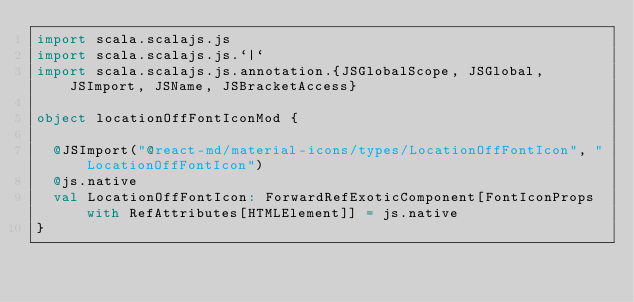Convert code to text. <code><loc_0><loc_0><loc_500><loc_500><_Scala_>import scala.scalajs.js
import scala.scalajs.js.`|`
import scala.scalajs.js.annotation.{JSGlobalScope, JSGlobal, JSImport, JSName, JSBracketAccess}

object locationOffFontIconMod {
  
  @JSImport("@react-md/material-icons/types/LocationOffFontIcon", "LocationOffFontIcon")
  @js.native
  val LocationOffFontIcon: ForwardRefExoticComponent[FontIconProps with RefAttributes[HTMLElement]] = js.native
}
</code> 